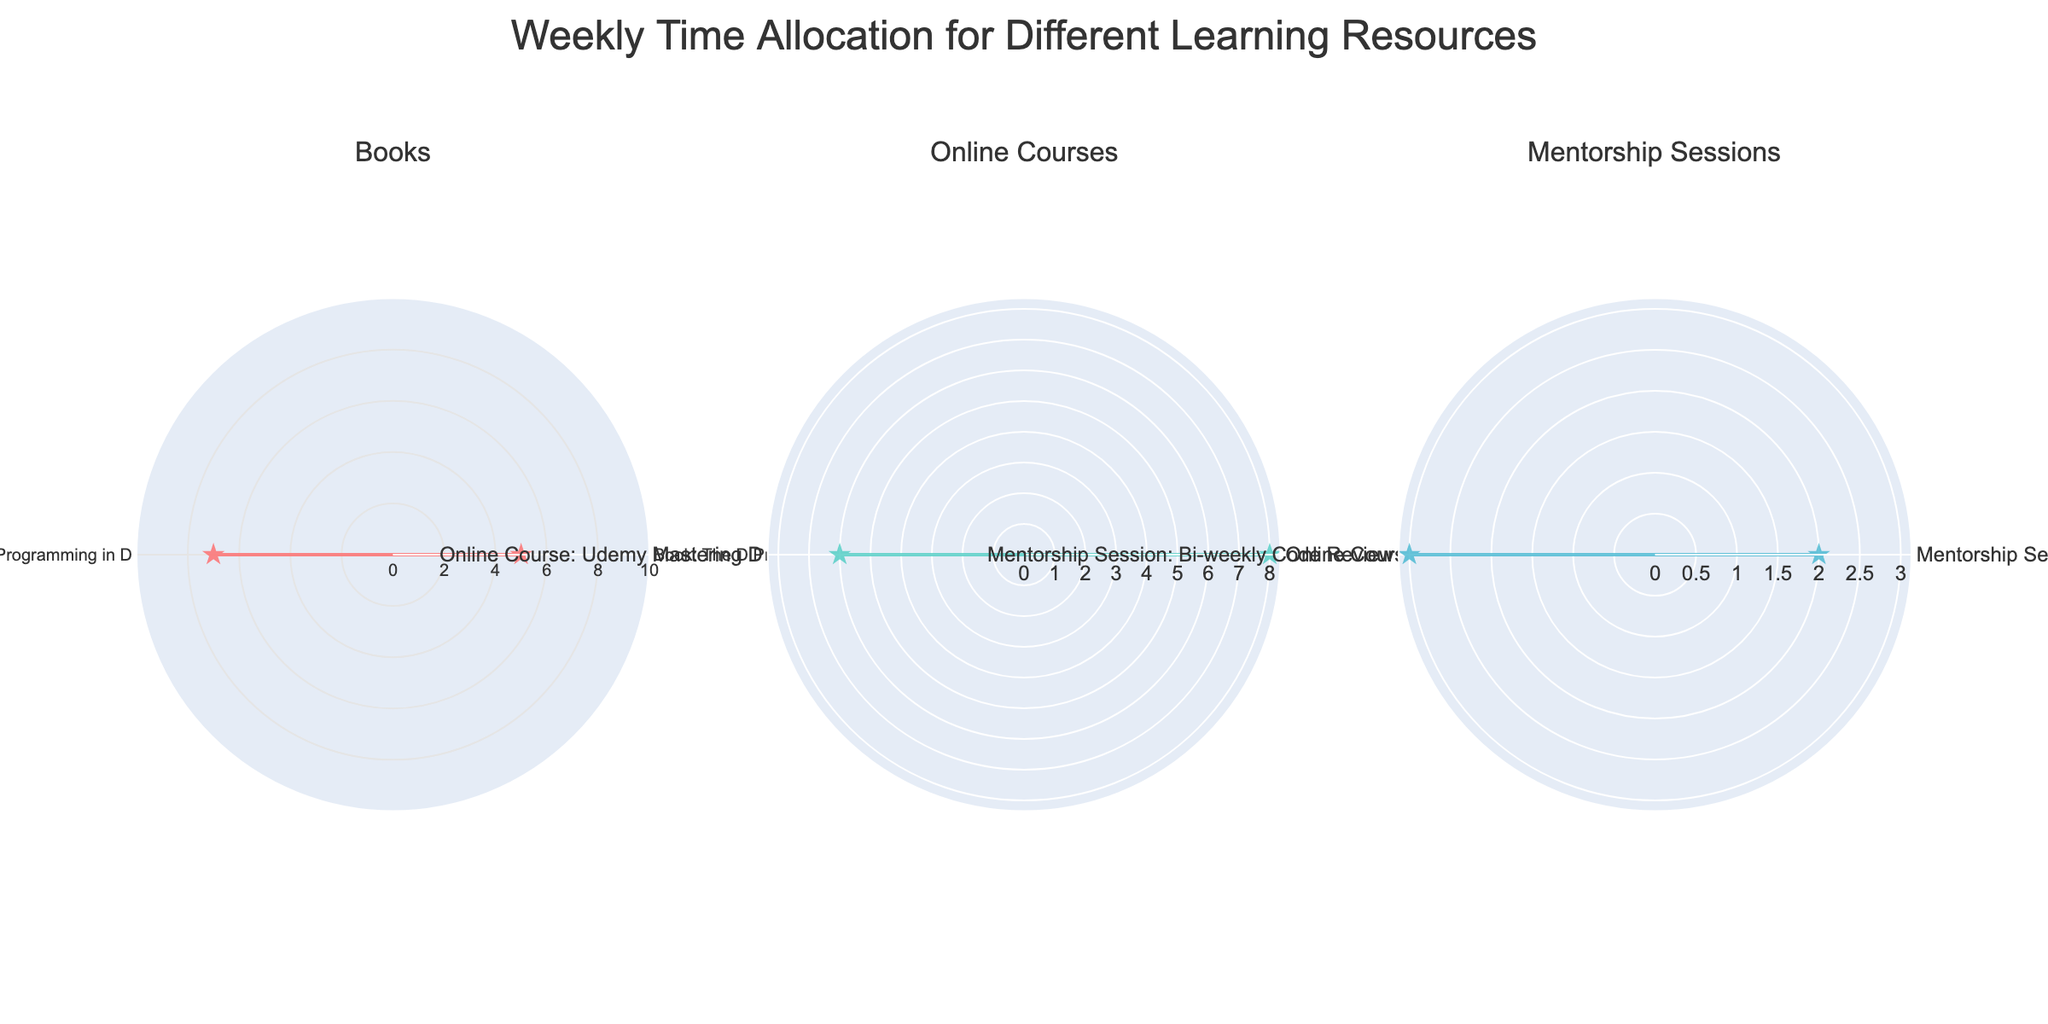What's the title of the figure? The title is typically displayed at the top of the figure. Here, it is placed in the center and reads "Weekly Time Allocation for Different Learning Resources".
Answer: Weekly Time Allocation for Different Learning Resources How many resource types are represented within the Books category? Looking at the subplot titled "Books", we can enumerate each resource listed. There are "Book: The D Programming Language" and "Book: Programming in D", which makes a total of 2 resources.
Answer: 2 In which category is the highest number of hours allocated to a single resource? By comparing the rings in each polar chart (Books, Online Courses, Mentorship Sessions), the tallest bar appears in the Online Courses section, specifically the "Online Course: Pluralsight D Programming" with 8 hours.
Answer: Online Courses What is the total time allocated to Mentorship Sessions? Mentorship Sessions include "Weekly with Senior Software Engineer" and "Bi-weekly Code Review". Summing up their allocated time: 2 hours + 3 hours = 5 hours.
Answer: 5 hours Which resource in the Mentorship Sessions category has more hours allocated to it? In the Mentorship Sessions category, "Bi-weekly Code Review" has 3 hours, while "Weekly with Senior Software Engineer" has 2 hours. Therefore, the "Bi-weekly Code Review" has more hours allocated.
Answer: Bi-weekly Code Review What is the difference in hours between the resource with the most allocated time and the one with the least allocated time? The resource with the most time is "Online Course: Pluralsight D Programming" with 8 hours. The one with the least time is "Weekly with Senior Software Engineer" with 2 hours. The difference is 8 - 2 = 6 hours.
Answer: 6 hours How are the data points visually represented in each polar subplot? Each data point is represented as a filled shape (filled with color and connected lines), emphasized with a star symbol to mark the points.
Answer: Filled shapes with star symbols On average, how many hours are allocated per resource in the Online Courses category? The Online Courses category consists of two resources: "Online Course: Pluralsight D Programming" (8 hours) and "Online Course: Udemy Mastering D" (6 hours). The average is computed as (8 + 6) / 2 = 7 hours.
Answer: 7 hours Which category appears to be receiving the most study hours in total? Adding up the hours for each category: 
Books: 5 + 7 = 12 hours 
Online Courses: 8 + 6 = 14 hours 
Mentorship Sessions: 2 + 3 = 5 hours 
Online Courses has the highest total with 14 hours.
Answer: Online Courses In the Books category, by how many hours does "Programming in D" exceed "The D Programming Language"? In the Books category, "Programming in D" has 7 hours while "The D Programming Language" has 5 hours. The difference is 7 - 5 = 2 hours.
Answer: 2 hours 